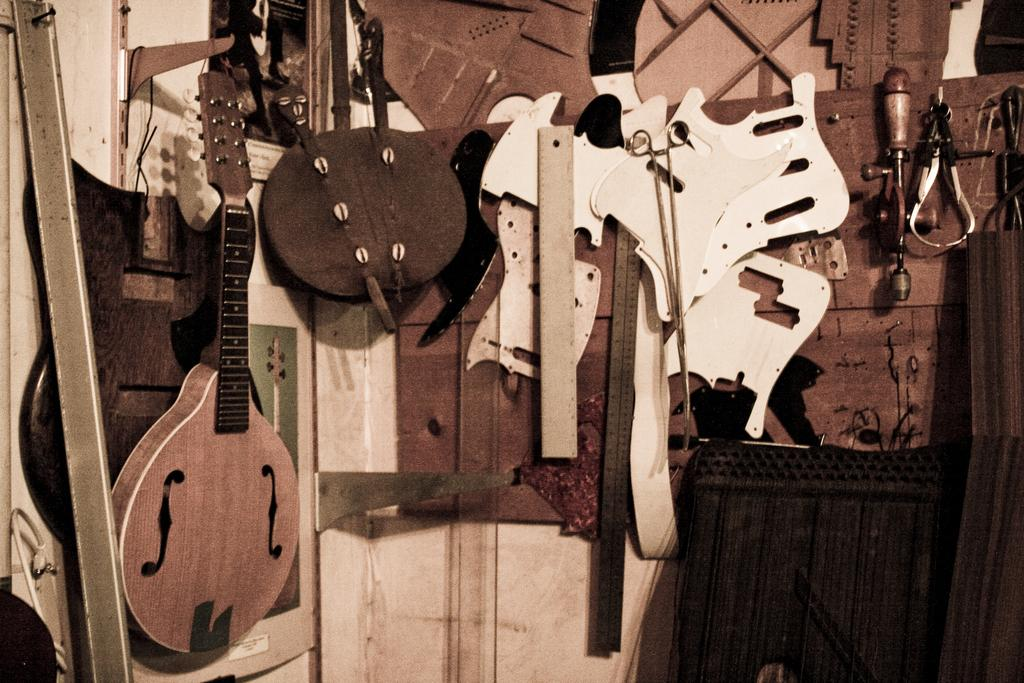What is the main object in the image? There is a guitar in the image. What else can be seen in the image besides the guitar? There is a bag and other musical instruments in the image. Where are the musical instruments placed? The musical instruments are placed on the wall. What is at the bottom of the image? There is a black table at the bottom of the image. Where is the faucet located in the image? There is no faucet present in the image. What type of tree can be seen growing through the guitar in the image? There is no tree growing through the guitar in the image; it is a guitar and other musical instruments placed on the wall. 